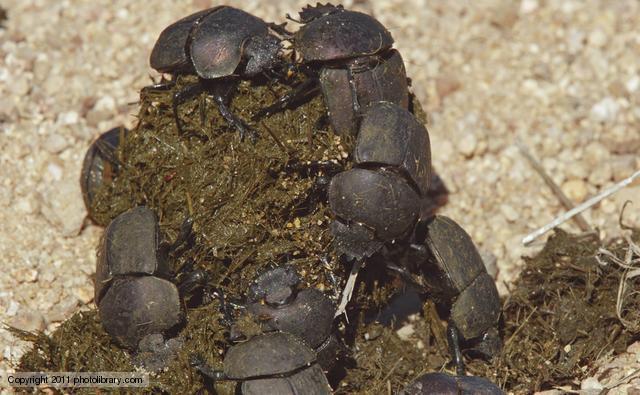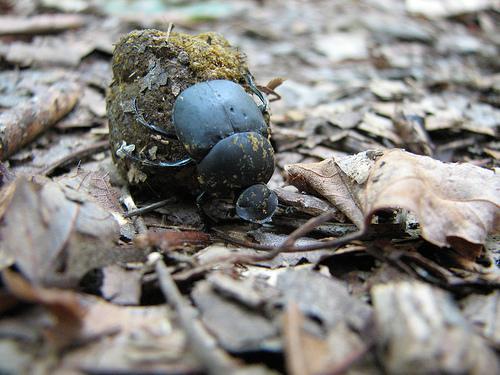The first image is the image on the left, the second image is the image on the right. For the images shown, is this caption "Each image includes at least one brown ball and one beetle in contact with it, but no image contains more than two beetles." true? Answer yes or no. No. The first image is the image on the left, the second image is the image on the right. Analyze the images presented: Is the assertion "There are multiple beetles near the dung in one of the images." valid? Answer yes or no. Yes. 